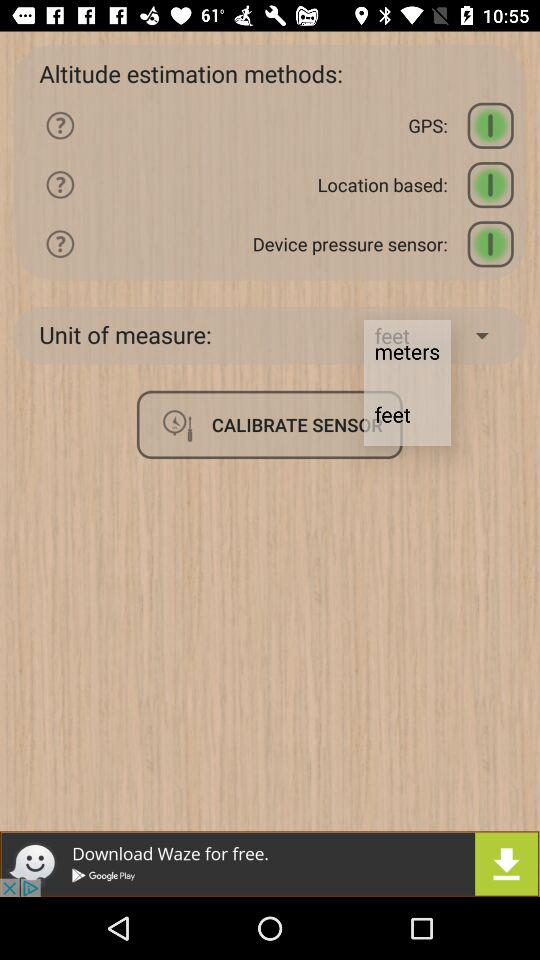How many altitude estimation methods are there?
Answer the question using a single word or phrase. 3 